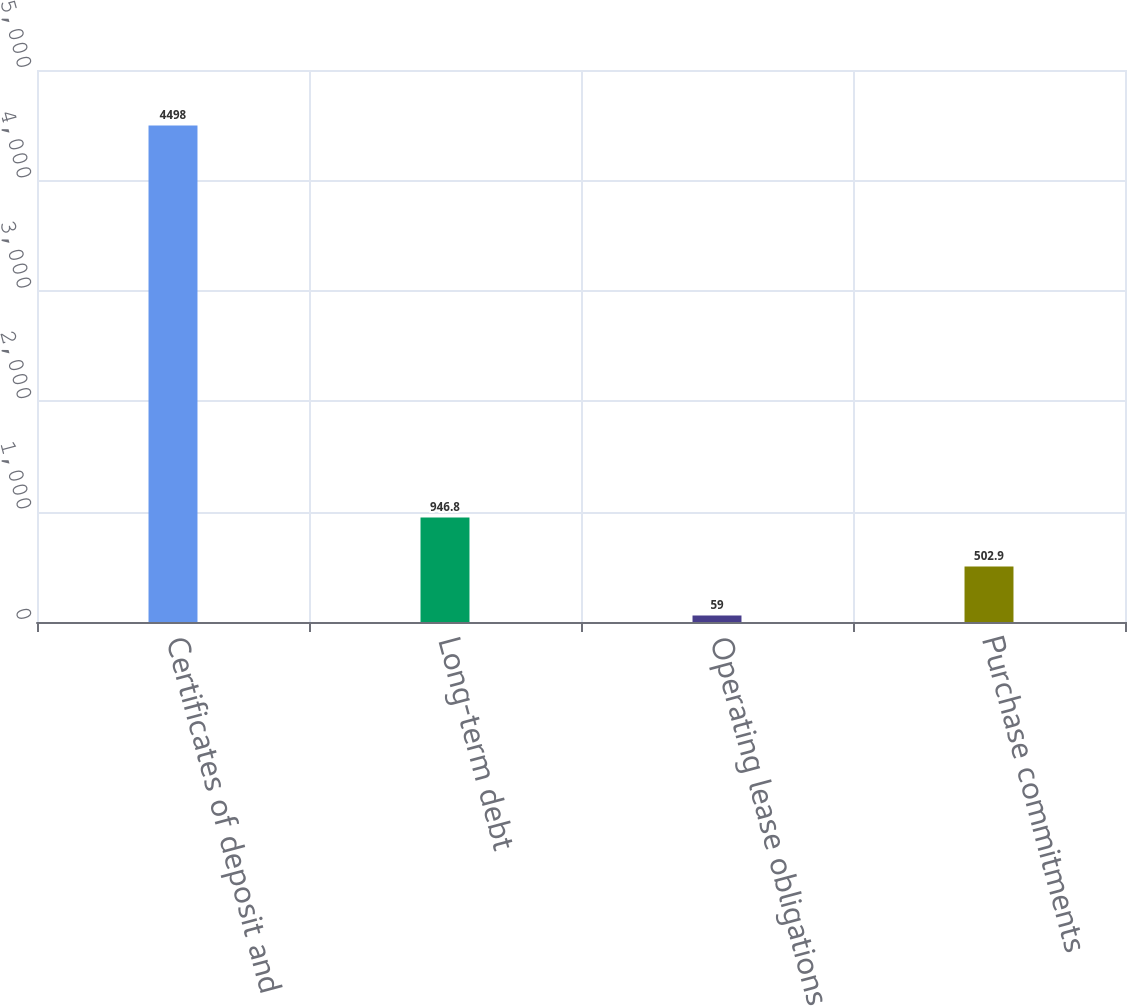<chart> <loc_0><loc_0><loc_500><loc_500><bar_chart><fcel>Certificates of deposit and<fcel>Long-term debt<fcel>Operating lease obligations<fcel>Purchase commitments<nl><fcel>4498<fcel>946.8<fcel>59<fcel>502.9<nl></chart> 